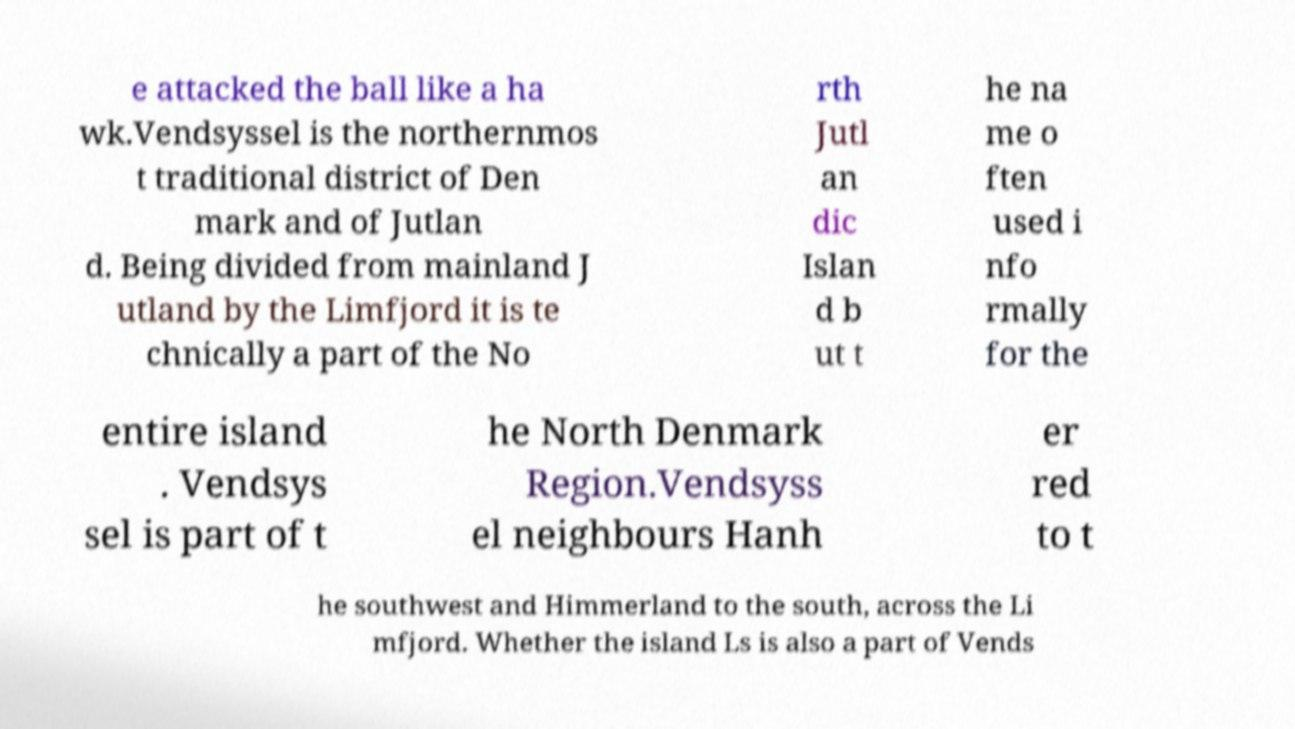Can you read and provide the text displayed in the image?This photo seems to have some interesting text. Can you extract and type it out for me? e attacked the ball like a ha wk.Vendsyssel is the northernmos t traditional district of Den mark and of Jutlan d. Being divided from mainland J utland by the Limfjord it is te chnically a part of the No rth Jutl an dic Islan d b ut t he na me o ften used i nfo rmally for the entire island . Vendsys sel is part of t he North Denmark Region.Vendsyss el neighbours Hanh er red to t he southwest and Himmerland to the south, across the Li mfjord. Whether the island Ls is also a part of Vends 